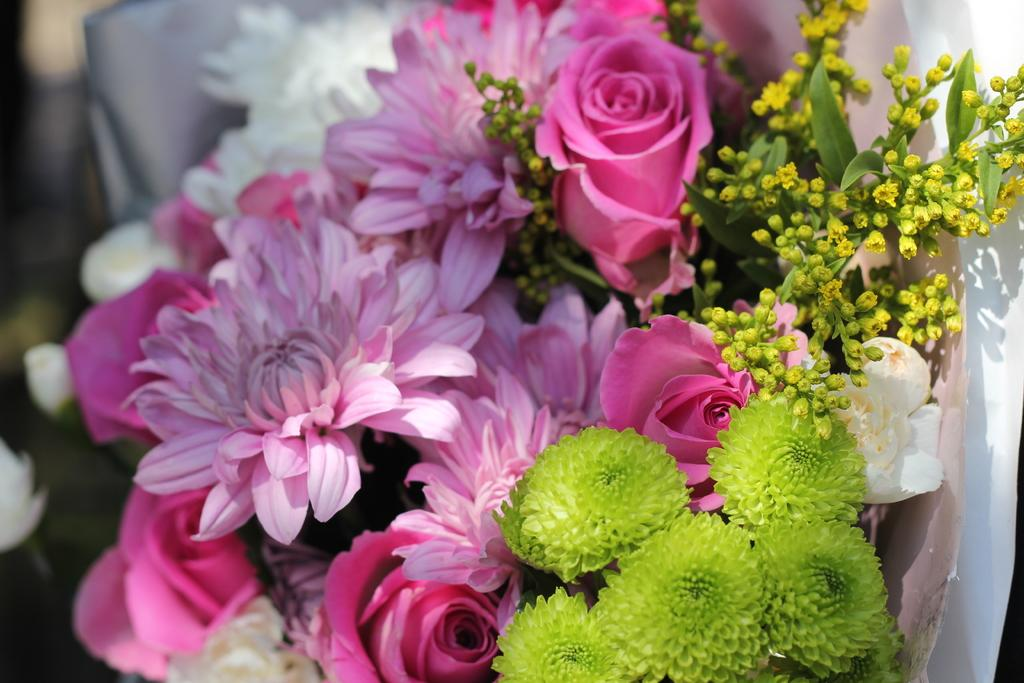What type of plants can be seen in the picture? There are flowers in the picture. Can you describe the background of the image? The background of the image is blurred. What type of chess piece is present in the image? There is no chess piece present in the image; it features flowers and a blurred background. 